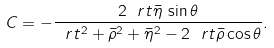<formula> <loc_0><loc_0><loc_500><loc_500>C = - \frac { 2 \ r t \bar { \eta } \, \sin \theta } { \ r t ^ { 2 } + \bar { \rho } ^ { 2 } + \bar { \eta } ^ { 2 } - 2 \ r t \bar { \rho } \cos \theta } .</formula> 